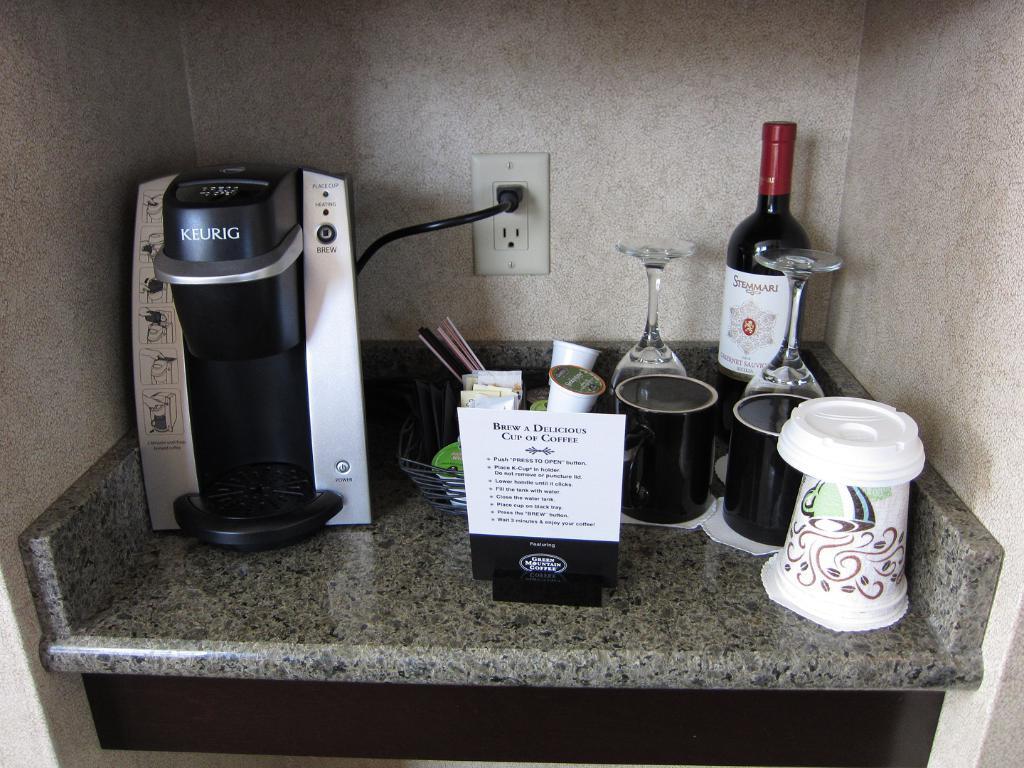Describe this image in one or two sentences. This is a coffee machine,two black cups,wine glasses,wine bottle ,a basket with some objects and a paper placed on the marble stone. This is the socket attached to the wall. 